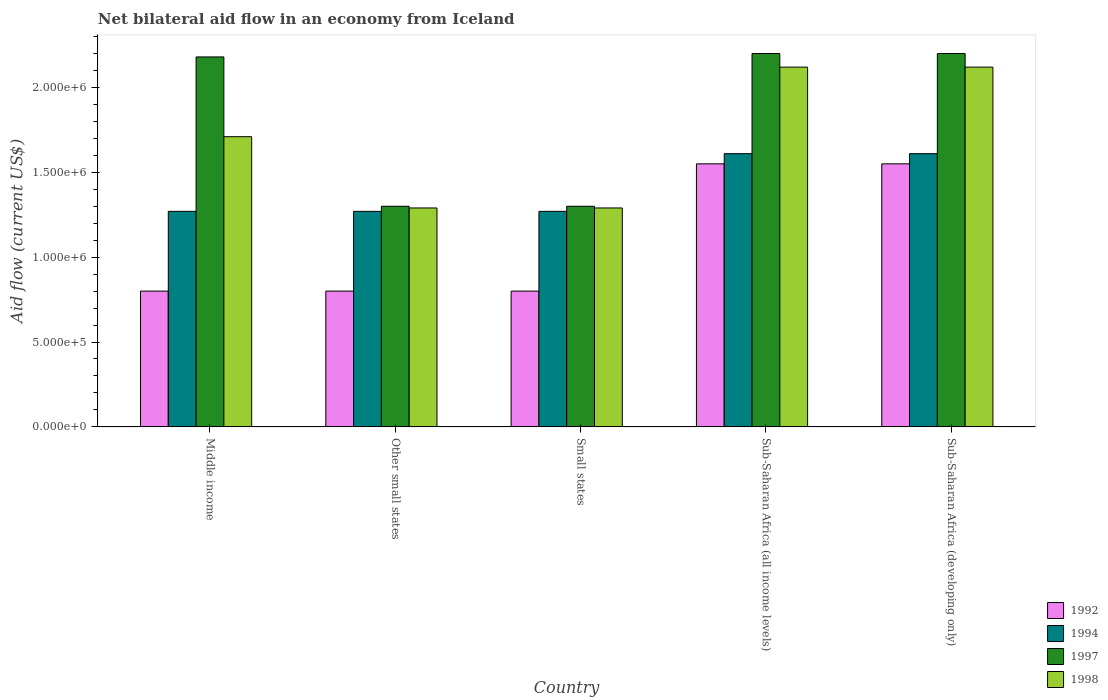How many different coloured bars are there?
Offer a terse response. 4. Are the number of bars per tick equal to the number of legend labels?
Make the answer very short. Yes. Are the number of bars on each tick of the X-axis equal?
Ensure brevity in your answer.  Yes. How many bars are there on the 4th tick from the left?
Your answer should be very brief. 4. What is the label of the 3rd group of bars from the left?
Ensure brevity in your answer.  Small states. In how many cases, is the number of bars for a given country not equal to the number of legend labels?
Provide a succinct answer. 0. What is the net bilateral aid flow in 1997 in Sub-Saharan Africa (developing only)?
Offer a terse response. 2.20e+06. Across all countries, what is the maximum net bilateral aid flow in 1994?
Give a very brief answer. 1.61e+06. Across all countries, what is the minimum net bilateral aid flow in 1994?
Give a very brief answer. 1.27e+06. In which country was the net bilateral aid flow in 1992 maximum?
Your answer should be compact. Sub-Saharan Africa (all income levels). What is the total net bilateral aid flow in 1997 in the graph?
Provide a short and direct response. 9.18e+06. What is the difference between the net bilateral aid flow in 1997 in Small states and that in Sub-Saharan Africa (developing only)?
Your answer should be very brief. -9.00e+05. What is the average net bilateral aid flow in 1994 per country?
Offer a terse response. 1.41e+06. What is the difference between the net bilateral aid flow of/in 1994 and net bilateral aid flow of/in 1997 in Sub-Saharan Africa (developing only)?
Your answer should be compact. -5.90e+05. What is the ratio of the net bilateral aid flow in 1997 in Middle income to that in Small states?
Your answer should be compact. 1.68. Is the net bilateral aid flow in 1994 in Small states less than that in Sub-Saharan Africa (developing only)?
Your response must be concise. Yes. What is the difference between the highest and the lowest net bilateral aid flow in 1992?
Offer a very short reply. 7.50e+05. In how many countries, is the net bilateral aid flow in 1998 greater than the average net bilateral aid flow in 1998 taken over all countries?
Provide a short and direct response. 3. Is the sum of the net bilateral aid flow in 1994 in Other small states and Sub-Saharan Africa (developing only) greater than the maximum net bilateral aid flow in 1997 across all countries?
Ensure brevity in your answer.  Yes. What does the 4th bar from the right in Other small states represents?
Keep it short and to the point. 1992. Is it the case that in every country, the sum of the net bilateral aid flow in 1992 and net bilateral aid flow in 1994 is greater than the net bilateral aid flow in 1998?
Your response must be concise. Yes. How many bars are there?
Offer a very short reply. 20. Are all the bars in the graph horizontal?
Your answer should be compact. No. How many countries are there in the graph?
Keep it short and to the point. 5. What is the difference between two consecutive major ticks on the Y-axis?
Ensure brevity in your answer.  5.00e+05. Are the values on the major ticks of Y-axis written in scientific E-notation?
Keep it short and to the point. Yes. Does the graph contain grids?
Keep it short and to the point. No. How are the legend labels stacked?
Your response must be concise. Vertical. What is the title of the graph?
Make the answer very short. Net bilateral aid flow in an economy from Iceland. What is the label or title of the X-axis?
Keep it short and to the point. Country. What is the label or title of the Y-axis?
Make the answer very short. Aid flow (current US$). What is the Aid flow (current US$) in 1994 in Middle income?
Your answer should be compact. 1.27e+06. What is the Aid flow (current US$) in 1997 in Middle income?
Your answer should be very brief. 2.18e+06. What is the Aid flow (current US$) of 1998 in Middle income?
Ensure brevity in your answer.  1.71e+06. What is the Aid flow (current US$) of 1994 in Other small states?
Provide a succinct answer. 1.27e+06. What is the Aid flow (current US$) in 1997 in Other small states?
Make the answer very short. 1.30e+06. What is the Aid flow (current US$) of 1998 in Other small states?
Provide a succinct answer. 1.29e+06. What is the Aid flow (current US$) in 1994 in Small states?
Your response must be concise. 1.27e+06. What is the Aid flow (current US$) in 1997 in Small states?
Make the answer very short. 1.30e+06. What is the Aid flow (current US$) in 1998 in Small states?
Provide a succinct answer. 1.29e+06. What is the Aid flow (current US$) in 1992 in Sub-Saharan Africa (all income levels)?
Provide a succinct answer. 1.55e+06. What is the Aid flow (current US$) in 1994 in Sub-Saharan Africa (all income levels)?
Your response must be concise. 1.61e+06. What is the Aid flow (current US$) of 1997 in Sub-Saharan Africa (all income levels)?
Keep it short and to the point. 2.20e+06. What is the Aid flow (current US$) in 1998 in Sub-Saharan Africa (all income levels)?
Keep it short and to the point. 2.12e+06. What is the Aid flow (current US$) in 1992 in Sub-Saharan Africa (developing only)?
Provide a short and direct response. 1.55e+06. What is the Aid flow (current US$) of 1994 in Sub-Saharan Africa (developing only)?
Offer a very short reply. 1.61e+06. What is the Aid flow (current US$) of 1997 in Sub-Saharan Africa (developing only)?
Give a very brief answer. 2.20e+06. What is the Aid flow (current US$) of 1998 in Sub-Saharan Africa (developing only)?
Provide a succinct answer. 2.12e+06. Across all countries, what is the maximum Aid flow (current US$) of 1992?
Make the answer very short. 1.55e+06. Across all countries, what is the maximum Aid flow (current US$) in 1994?
Your response must be concise. 1.61e+06. Across all countries, what is the maximum Aid flow (current US$) of 1997?
Your answer should be compact. 2.20e+06. Across all countries, what is the maximum Aid flow (current US$) of 1998?
Make the answer very short. 2.12e+06. Across all countries, what is the minimum Aid flow (current US$) of 1994?
Make the answer very short. 1.27e+06. Across all countries, what is the minimum Aid flow (current US$) of 1997?
Make the answer very short. 1.30e+06. Across all countries, what is the minimum Aid flow (current US$) in 1998?
Provide a short and direct response. 1.29e+06. What is the total Aid flow (current US$) in 1992 in the graph?
Offer a terse response. 5.50e+06. What is the total Aid flow (current US$) in 1994 in the graph?
Offer a very short reply. 7.03e+06. What is the total Aid flow (current US$) in 1997 in the graph?
Your answer should be very brief. 9.18e+06. What is the total Aid flow (current US$) in 1998 in the graph?
Your answer should be very brief. 8.53e+06. What is the difference between the Aid flow (current US$) in 1992 in Middle income and that in Other small states?
Give a very brief answer. 0. What is the difference between the Aid flow (current US$) in 1997 in Middle income and that in Other small states?
Keep it short and to the point. 8.80e+05. What is the difference between the Aid flow (current US$) of 1998 in Middle income and that in Other small states?
Your answer should be very brief. 4.20e+05. What is the difference between the Aid flow (current US$) in 1997 in Middle income and that in Small states?
Your answer should be very brief. 8.80e+05. What is the difference between the Aid flow (current US$) in 1998 in Middle income and that in Small states?
Ensure brevity in your answer.  4.20e+05. What is the difference between the Aid flow (current US$) in 1992 in Middle income and that in Sub-Saharan Africa (all income levels)?
Your response must be concise. -7.50e+05. What is the difference between the Aid flow (current US$) in 1994 in Middle income and that in Sub-Saharan Africa (all income levels)?
Offer a terse response. -3.40e+05. What is the difference between the Aid flow (current US$) in 1998 in Middle income and that in Sub-Saharan Africa (all income levels)?
Your response must be concise. -4.10e+05. What is the difference between the Aid flow (current US$) in 1992 in Middle income and that in Sub-Saharan Africa (developing only)?
Offer a terse response. -7.50e+05. What is the difference between the Aid flow (current US$) of 1998 in Middle income and that in Sub-Saharan Africa (developing only)?
Your answer should be compact. -4.10e+05. What is the difference between the Aid flow (current US$) in 1992 in Other small states and that in Small states?
Ensure brevity in your answer.  0. What is the difference between the Aid flow (current US$) of 1994 in Other small states and that in Small states?
Your answer should be very brief. 0. What is the difference between the Aid flow (current US$) of 1997 in Other small states and that in Small states?
Offer a very short reply. 0. What is the difference between the Aid flow (current US$) in 1992 in Other small states and that in Sub-Saharan Africa (all income levels)?
Give a very brief answer. -7.50e+05. What is the difference between the Aid flow (current US$) in 1997 in Other small states and that in Sub-Saharan Africa (all income levels)?
Give a very brief answer. -9.00e+05. What is the difference between the Aid flow (current US$) in 1998 in Other small states and that in Sub-Saharan Africa (all income levels)?
Your answer should be compact. -8.30e+05. What is the difference between the Aid flow (current US$) in 1992 in Other small states and that in Sub-Saharan Africa (developing only)?
Your answer should be very brief. -7.50e+05. What is the difference between the Aid flow (current US$) in 1997 in Other small states and that in Sub-Saharan Africa (developing only)?
Give a very brief answer. -9.00e+05. What is the difference between the Aid flow (current US$) in 1998 in Other small states and that in Sub-Saharan Africa (developing only)?
Provide a succinct answer. -8.30e+05. What is the difference between the Aid flow (current US$) of 1992 in Small states and that in Sub-Saharan Africa (all income levels)?
Ensure brevity in your answer.  -7.50e+05. What is the difference between the Aid flow (current US$) of 1994 in Small states and that in Sub-Saharan Africa (all income levels)?
Provide a short and direct response. -3.40e+05. What is the difference between the Aid flow (current US$) of 1997 in Small states and that in Sub-Saharan Africa (all income levels)?
Provide a succinct answer. -9.00e+05. What is the difference between the Aid flow (current US$) in 1998 in Small states and that in Sub-Saharan Africa (all income levels)?
Your answer should be very brief. -8.30e+05. What is the difference between the Aid flow (current US$) in 1992 in Small states and that in Sub-Saharan Africa (developing only)?
Your answer should be compact. -7.50e+05. What is the difference between the Aid flow (current US$) of 1997 in Small states and that in Sub-Saharan Africa (developing only)?
Provide a short and direct response. -9.00e+05. What is the difference between the Aid flow (current US$) in 1998 in Small states and that in Sub-Saharan Africa (developing only)?
Your answer should be very brief. -8.30e+05. What is the difference between the Aid flow (current US$) in 1992 in Sub-Saharan Africa (all income levels) and that in Sub-Saharan Africa (developing only)?
Provide a succinct answer. 0. What is the difference between the Aid flow (current US$) in 1994 in Sub-Saharan Africa (all income levels) and that in Sub-Saharan Africa (developing only)?
Give a very brief answer. 0. What is the difference between the Aid flow (current US$) in 1997 in Sub-Saharan Africa (all income levels) and that in Sub-Saharan Africa (developing only)?
Ensure brevity in your answer.  0. What is the difference between the Aid flow (current US$) of 1998 in Sub-Saharan Africa (all income levels) and that in Sub-Saharan Africa (developing only)?
Offer a very short reply. 0. What is the difference between the Aid flow (current US$) in 1992 in Middle income and the Aid flow (current US$) in 1994 in Other small states?
Your answer should be very brief. -4.70e+05. What is the difference between the Aid flow (current US$) of 1992 in Middle income and the Aid flow (current US$) of 1997 in Other small states?
Provide a short and direct response. -5.00e+05. What is the difference between the Aid flow (current US$) of 1992 in Middle income and the Aid flow (current US$) of 1998 in Other small states?
Ensure brevity in your answer.  -4.90e+05. What is the difference between the Aid flow (current US$) of 1994 in Middle income and the Aid flow (current US$) of 1997 in Other small states?
Provide a succinct answer. -3.00e+04. What is the difference between the Aid flow (current US$) in 1997 in Middle income and the Aid flow (current US$) in 1998 in Other small states?
Your answer should be compact. 8.90e+05. What is the difference between the Aid flow (current US$) of 1992 in Middle income and the Aid flow (current US$) of 1994 in Small states?
Your response must be concise. -4.70e+05. What is the difference between the Aid flow (current US$) of 1992 in Middle income and the Aid flow (current US$) of 1997 in Small states?
Offer a very short reply. -5.00e+05. What is the difference between the Aid flow (current US$) of 1992 in Middle income and the Aid flow (current US$) of 1998 in Small states?
Make the answer very short. -4.90e+05. What is the difference between the Aid flow (current US$) in 1994 in Middle income and the Aid flow (current US$) in 1998 in Small states?
Offer a terse response. -2.00e+04. What is the difference between the Aid flow (current US$) of 1997 in Middle income and the Aid flow (current US$) of 1998 in Small states?
Provide a short and direct response. 8.90e+05. What is the difference between the Aid flow (current US$) of 1992 in Middle income and the Aid flow (current US$) of 1994 in Sub-Saharan Africa (all income levels)?
Give a very brief answer. -8.10e+05. What is the difference between the Aid flow (current US$) of 1992 in Middle income and the Aid flow (current US$) of 1997 in Sub-Saharan Africa (all income levels)?
Your answer should be very brief. -1.40e+06. What is the difference between the Aid flow (current US$) in 1992 in Middle income and the Aid flow (current US$) in 1998 in Sub-Saharan Africa (all income levels)?
Ensure brevity in your answer.  -1.32e+06. What is the difference between the Aid flow (current US$) in 1994 in Middle income and the Aid flow (current US$) in 1997 in Sub-Saharan Africa (all income levels)?
Offer a very short reply. -9.30e+05. What is the difference between the Aid flow (current US$) of 1994 in Middle income and the Aid flow (current US$) of 1998 in Sub-Saharan Africa (all income levels)?
Offer a very short reply. -8.50e+05. What is the difference between the Aid flow (current US$) in 1992 in Middle income and the Aid flow (current US$) in 1994 in Sub-Saharan Africa (developing only)?
Offer a terse response. -8.10e+05. What is the difference between the Aid flow (current US$) in 1992 in Middle income and the Aid flow (current US$) in 1997 in Sub-Saharan Africa (developing only)?
Provide a succinct answer. -1.40e+06. What is the difference between the Aid flow (current US$) in 1992 in Middle income and the Aid flow (current US$) in 1998 in Sub-Saharan Africa (developing only)?
Your response must be concise. -1.32e+06. What is the difference between the Aid flow (current US$) of 1994 in Middle income and the Aid flow (current US$) of 1997 in Sub-Saharan Africa (developing only)?
Your answer should be compact. -9.30e+05. What is the difference between the Aid flow (current US$) of 1994 in Middle income and the Aid flow (current US$) of 1998 in Sub-Saharan Africa (developing only)?
Provide a succinct answer. -8.50e+05. What is the difference between the Aid flow (current US$) in 1992 in Other small states and the Aid flow (current US$) in 1994 in Small states?
Your answer should be very brief. -4.70e+05. What is the difference between the Aid flow (current US$) in 1992 in Other small states and the Aid flow (current US$) in 1997 in Small states?
Provide a short and direct response. -5.00e+05. What is the difference between the Aid flow (current US$) of 1992 in Other small states and the Aid flow (current US$) of 1998 in Small states?
Make the answer very short. -4.90e+05. What is the difference between the Aid flow (current US$) of 1994 in Other small states and the Aid flow (current US$) of 1998 in Small states?
Make the answer very short. -2.00e+04. What is the difference between the Aid flow (current US$) in 1992 in Other small states and the Aid flow (current US$) in 1994 in Sub-Saharan Africa (all income levels)?
Keep it short and to the point. -8.10e+05. What is the difference between the Aid flow (current US$) in 1992 in Other small states and the Aid flow (current US$) in 1997 in Sub-Saharan Africa (all income levels)?
Offer a very short reply. -1.40e+06. What is the difference between the Aid flow (current US$) in 1992 in Other small states and the Aid flow (current US$) in 1998 in Sub-Saharan Africa (all income levels)?
Provide a short and direct response. -1.32e+06. What is the difference between the Aid flow (current US$) in 1994 in Other small states and the Aid flow (current US$) in 1997 in Sub-Saharan Africa (all income levels)?
Make the answer very short. -9.30e+05. What is the difference between the Aid flow (current US$) of 1994 in Other small states and the Aid flow (current US$) of 1998 in Sub-Saharan Africa (all income levels)?
Your answer should be compact. -8.50e+05. What is the difference between the Aid flow (current US$) of 1997 in Other small states and the Aid flow (current US$) of 1998 in Sub-Saharan Africa (all income levels)?
Ensure brevity in your answer.  -8.20e+05. What is the difference between the Aid flow (current US$) of 1992 in Other small states and the Aid flow (current US$) of 1994 in Sub-Saharan Africa (developing only)?
Your answer should be very brief. -8.10e+05. What is the difference between the Aid flow (current US$) of 1992 in Other small states and the Aid flow (current US$) of 1997 in Sub-Saharan Africa (developing only)?
Provide a short and direct response. -1.40e+06. What is the difference between the Aid flow (current US$) of 1992 in Other small states and the Aid flow (current US$) of 1998 in Sub-Saharan Africa (developing only)?
Provide a succinct answer. -1.32e+06. What is the difference between the Aid flow (current US$) in 1994 in Other small states and the Aid flow (current US$) in 1997 in Sub-Saharan Africa (developing only)?
Provide a short and direct response. -9.30e+05. What is the difference between the Aid flow (current US$) in 1994 in Other small states and the Aid flow (current US$) in 1998 in Sub-Saharan Africa (developing only)?
Give a very brief answer. -8.50e+05. What is the difference between the Aid flow (current US$) in 1997 in Other small states and the Aid flow (current US$) in 1998 in Sub-Saharan Africa (developing only)?
Give a very brief answer. -8.20e+05. What is the difference between the Aid flow (current US$) of 1992 in Small states and the Aid flow (current US$) of 1994 in Sub-Saharan Africa (all income levels)?
Offer a very short reply. -8.10e+05. What is the difference between the Aid flow (current US$) of 1992 in Small states and the Aid flow (current US$) of 1997 in Sub-Saharan Africa (all income levels)?
Make the answer very short. -1.40e+06. What is the difference between the Aid flow (current US$) of 1992 in Small states and the Aid flow (current US$) of 1998 in Sub-Saharan Africa (all income levels)?
Your answer should be compact. -1.32e+06. What is the difference between the Aid flow (current US$) in 1994 in Small states and the Aid flow (current US$) in 1997 in Sub-Saharan Africa (all income levels)?
Your answer should be very brief. -9.30e+05. What is the difference between the Aid flow (current US$) of 1994 in Small states and the Aid flow (current US$) of 1998 in Sub-Saharan Africa (all income levels)?
Your response must be concise. -8.50e+05. What is the difference between the Aid flow (current US$) of 1997 in Small states and the Aid flow (current US$) of 1998 in Sub-Saharan Africa (all income levels)?
Your answer should be compact. -8.20e+05. What is the difference between the Aid flow (current US$) of 1992 in Small states and the Aid flow (current US$) of 1994 in Sub-Saharan Africa (developing only)?
Your answer should be very brief. -8.10e+05. What is the difference between the Aid flow (current US$) of 1992 in Small states and the Aid flow (current US$) of 1997 in Sub-Saharan Africa (developing only)?
Provide a succinct answer. -1.40e+06. What is the difference between the Aid flow (current US$) in 1992 in Small states and the Aid flow (current US$) in 1998 in Sub-Saharan Africa (developing only)?
Offer a very short reply. -1.32e+06. What is the difference between the Aid flow (current US$) in 1994 in Small states and the Aid flow (current US$) in 1997 in Sub-Saharan Africa (developing only)?
Your response must be concise. -9.30e+05. What is the difference between the Aid flow (current US$) of 1994 in Small states and the Aid flow (current US$) of 1998 in Sub-Saharan Africa (developing only)?
Ensure brevity in your answer.  -8.50e+05. What is the difference between the Aid flow (current US$) of 1997 in Small states and the Aid flow (current US$) of 1998 in Sub-Saharan Africa (developing only)?
Your answer should be compact. -8.20e+05. What is the difference between the Aid flow (current US$) of 1992 in Sub-Saharan Africa (all income levels) and the Aid flow (current US$) of 1994 in Sub-Saharan Africa (developing only)?
Provide a short and direct response. -6.00e+04. What is the difference between the Aid flow (current US$) in 1992 in Sub-Saharan Africa (all income levels) and the Aid flow (current US$) in 1997 in Sub-Saharan Africa (developing only)?
Provide a succinct answer. -6.50e+05. What is the difference between the Aid flow (current US$) of 1992 in Sub-Saharan Africa (all income levels) and the Aid flow (current US$) of 1998 in Sub-Saharan Africa (developing only)?
Keep it short and to the point. -5.70e+05. What is the difference between the Aid flow (current US$) of 1994 in Sub-Saharan Africa (all income levels) and the Aid flow (current US$) of 1997 in Sub-Saharan Africa (developing only)?
Provide a succinct answer. -5.90e+05. What is the difference between the Aid flow (current US$) in 1994 in Sub-Saharan Africa (all income levels) and the Aid flow (current US$) in 1998 in Sub-Saharan Africa (developing only)?
Ensure brevity in your answer.  -5.10e+05. What is the average Aid flow (current US$) in 1992 per country?
Your answer should be very brief. 1.10e+06. What is the average Aid flow (current US$) of 1994 per country?
Provide a short and direct response. 1.41e+06. What is the average Aid flow (current US$) of 1997 per country?
Ensure brevity in your answer.  1.84e+06. What is the average Aid flow (current US$) of 1998 per country?
Keep it short and to the point. 1.71e+06. What is the difference between the Aid flow (current US$) of 1992 and Aid flow (current US$) of 1994 in Middle income?
Offer a terse response. -4.70e+05. What is the difference between the Aid flow (current US$) in 1992 and Aid flow (current US$) in 1997 in Middle income?
Provide a succinct answer. -1.38e+06. What is the difference between the Aid flow (current US$) in 1992 and Aid flow (current US$) in 1998 in Middle income?
Your answer should be compact. -9.10e+05. What is the difference between the Aid flow (current US$) in 1994 and Aid flow (current US$) in 1997 in Middle income?
Your answer should be very brief. -9.10e+05. What is the difference between the Aid flow (current US$) of 1994 and Aid flow (current US$) of 1998 in Middle income?
Ensure brevity in your answer.  -4.40e+05. What is the difference between the Aid flow (current US$) in 1997 and Aid flow (current US$) in 1998 in Middle income?
Offer a terse response. 4.70e+05. What is the difference between the Aid flow (current US$) of 1992 and Aid flow (current US$) of 1994 in Other small states?
Provide a succinct answer. -4.70e+05. What is the difference between the Aid flow (current US$) in 1992 and Aid flow (current US$) in 1997 in Other small states?
Your response must be concise. -5.00e+05. What is the difference between the Aid flow (current US$) in 1992 and Aid flow (current US$) in 1998 in Other small states?
Your answer should be very brief. -4.90e+05. What is the difference between the Aid flow (current US$) of 1994 and Aid flow (current US$) of 1998 in Other small states?
Offer a terse response. -2.00e+04. What is the difference between the Aid flow (current US$) in 1997 and Aid flow (current US$) in 1998 in Other small states?
Ensure brevity in your answer.  10000. What is the difference between the Aid flow (current US$) in 1992 and Aid flow (current US$) in 1994 in Small states?
Your answer should be very brief. -4.70e+05. What is the difference between the Aid flow (current US$) of 1992 and Aid flow (current US$) of 1997 in Small states?
Provide a succinct answer. -5.00e+05. What is the difference between the Aid flow (current US$) in 1992 and Aid flow (current US$) in 1998 in Small states?
Your answer should be compact. -4.90e+05. What is the difference between the Aid flow (current US$) in 1997 and Aid flow (current US$) in 1998 in Small states?
Ensure brevity in your answer.  10000. What is the difference between the Aid flow (current US$) in 1992 and Aid flow (current US$) in 1997 in Sub-Saharan Africa (all income levels)?
Provide a short and direct response. -6.50e+05. What is the difference between the Aid flow (current US$) of 1992 and Aid flow (current US$) of 1998 in Sub-Saharan Africa (all income levels)?
Your answer should be very brief. -5.70e+05. What is the difference between the Aid flow (current US$) of 1994 and Aid flow (current US$) of 1997 in Sub-Saharan Africa (all income levels)?
Offer a terse response. -5.90e+05. What is the difference between the Aid flow (current US$) of 1994 and Aid flow (current US$) of 1998 in Sub-Saharan Africa (all income levels)?
Make the answer very short. -5.10e+05. What is the difference between the Aid flow (current US$) of 1992 and Aid flow (current US$) of 1997 in Sub-Saharan Africa (developing only)?
Keep it short and to the point. -6.50e+05. What is the difference between the Aid flow (current US$) of 1992 and Aid flow (current US$) of 1998 in Sub-Saharan Africa (developing only)?
Provide a short and direct response. -5.70e+05. What is the difference between the Aid flow (current US$) in 1994 and Aid flow (current US$) in 1997 in Sub-Saharan Africa (developing only)?
Give a very brief answer. -5.90e+05. What is the difference between the Aid flow (current US$) in 1994 and Aid flow (current US$) in 1998 in Sub-Saharan Africa (developing only)?
Ensure brevity in your answer.  -5.10e+05. What is the difference between the Aid flow (current US$) of 1997 and Aid flow (current US$) of 1998 in Sub-Saharan Africa (developing only)?
Give a very brief answer. 8.00e+04. What is the ratio of the Aid flow (current US$) of 1992 in Middle income to that in Other small states?
Your answer should be compact. 1. What is the ratio of the Aid flow (current US$) in 1997 in Middle income to that in Other small states?
Make the answer very short. 1.68. What is the ratio of the Aid flow (current US$) of 1998 in Middle income to that in Other small states?
Provide a succinct answer. 1.33. What is the ratio of the Aid flow (current US$) of 1997 in Middle income to that in Small states?
Provide a succinct answer. 1.68. What is the ratio of the Aid flow (current US$) of 1998 in Middle income to that in Small states?
Offer a very short reply. 1.33. What is the ratio of the Aid flow (current US$) in 1992 in Middle income to that in Sub-Saharan Africa (all income levels)?
Ensure brevity in your answer.  0.52. What is the ratio of the Aid flow (current US$) of 1994 in Middle income to that in Sub-Saharan Africa (all income levels)?
Ensure brevity in your answer.  0.79. What is the ratio of the Aid flow (current US$) of 1997 in Middle income to that in Sub-Saharan Africa (all income levels)?
Offer a very short reply. 0.99. What is the ratio of the Aid flow (current US$) in 1998 in Middle income to that in Sub-Saharan Africa (all income levels)?
Your response must be concise. 0.81. What is the ratio of the Aid flow (current US$) in 1992 in Middle income to that in Sub-Saharan Africa (developing only)?
Offer a very short reply. 0.52. What is the ratio of the Aid flow (current US$) in 1994 in Middle income to that in Sub-Saharan Africa (developing only)?
Provide a succinct answer. 0.79. What is the ratio of the Aid flow (current US$) of 1997 in Middle income to that in Sub-Saharan Africa (developing only)?
Offer a terse response. 0.99. What is the ratio of the Aid flow (current US$) in 1998 in Middle income to that in Sub-Saharan Africa (developing only)?
Your answer should be very brief. 0.81. What is the ratio of the Aid flow (current US$) of 1994 in Other small states to that in Small states?
Give a very brief answer. 1. What is the ratio of the Aid flow (current US$) of 1997 in Other small states to that in Small states?
Your answer should be very brief. 1. What is the ratio of the Aid flow (current US$) in 1992 in Other small states to that in Sub-Saharan Africa (all income levels)?
Keep it short and to the point. 0.52. What is the ratio of the Aid flow (current US$) in 1994 in Other small states to that in Sub-Saharan Africa (all income levels)?
Keep it short and to the point. 0.79. What is the ratio of the Aid flow (current US$) of 1997 in Other small states to that in Sub-Saharan Africa (all income levels)?
Your answer should be compact. 0.59. What is the ratio of the Aid flow (current US$) of 1998 in Other small states to that in Sub-Saharan Africa (all income levels)?
Give a very brief answer. 0.61. What is the ratio of the Aid flow (current US$) of 1992 in Other small states to that in Sub-Saharan Africa (developing only)?
Your response must be concise. 0.52. What is the ratio of the Aid flow (current US$) of 1994 in Other small states to that in Sub-Saharan Africa (developing only)?
Your response must be concise. 0.79. What is the ratio of the Aid flow (current US$) in 1997 in Other small states to that in Sub-Saharan Africa (developing only)?
Offer a terse response. 0.59. What is the ratio of the Aid flow (current US$) in 1998 in Other small states to that in Sub-Saharan Africa (developing only)?
Offer a terse response. 0.61. What is the ratio of the Aid flow (current US$) in 1992 in Small states to that in Sub-Saharan Africa (all income levels)?
Your answer should be compact. 0.52. What is the ratio of the Aid flow (current US$) of 1994 in Small states to that in Sub-Saharan Africa (all income levels)?
Give a very brief answer. 0.79. What is the ratio of the Aid flow (current US$) in 1997 in Small states to that in Sub-Saharan Africa (all income levels)?
Your answer should be compact. 0.59. What is the ratio of the Aid flow (current US$) of 1998 in Small states to that in Sub-Saharan Africa (all income levels)?
Your response must be concise. 0.61. What is the ratio of the Aid flow (current US$) in 1992 in Small states to that in Sub-Saharan Africa (developing only)?
Your response must be concise. 0.52. What is the ratio of the Aid flow (current US$) in 1994 in Small states to that in Sub-Saharan Africa (developing only)?
Offer a very short reply. 0.79. What is the ratio of the Aid flow (current US$) of 1997 in Small states to that in Sub-Saharan Africa (developing only)?
Keep it short and to the point. 0.59. What is the ratio of the Aid flow (current US$) in 1998 in Small states to that in Sub-Saharan Africa (developing only)?
Ensure brevity in your answer.  0.61. What is the ratio of the Aid flow (current US$) of 1992 in Sub-Saharan Africa (all income levels) to that in Sub-Saharan Africa (developing only)?
Make the answer very short. 1. What is the ratio of the Aid flow (current US$) of 1994 in Sub-Saharan Africa (all income levels) to that in Sub-Saharan Africa (developing only)?
Your response must be concise. 1. What is the ratio of the Aid flow (current US$) in 1997 in Sub-Saharan Africa (all income levels) to that in Sub-Saharan Africa (developing only)?
Provide a succinct answer. 1. What is the difference between the highest and the second highest Aid flow (current US$) in 1992?
Keep it short and to the point. 0. What is the difference between the highest and the second highest Aid flow (current US$) of 1997?
Your answer should be very brief. 0. What is the difference between the highest and the second highest Aid flow (current US$) in 1998?
Your answer should be very brief. 0. What is the difference between the highest and the lowest Aid flow (current US$) in 1992?
Provide a short and direct response. 7.50e+05. What is the difference between the highest and the lowest Aid flow (current US$) of 1994?
Your answer should be compact. 3.40e+05. What is the difference between the highest and the lowest Aid flow (current US$) of 1997?
Provide a succinct answer. 9.00e+05. What is the difference between the highest and the lowest Aid flow (current US$) in 1998?
Your response must be concise. 8.30e+05. 